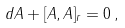Convert formula to latex. <formula><loc_0><loc_0><loc_500><loc_500>d A + [ { A } , { A } ] _ { r } = 0 \, ,</formula> 